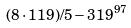Convert formula to latex. <formula><loc_0><loc_0><loc_500><loc_500>( 8 \cdot 1 1 9 ) / 5 - 3 1 9 ^ { 9 7 }</formula> 